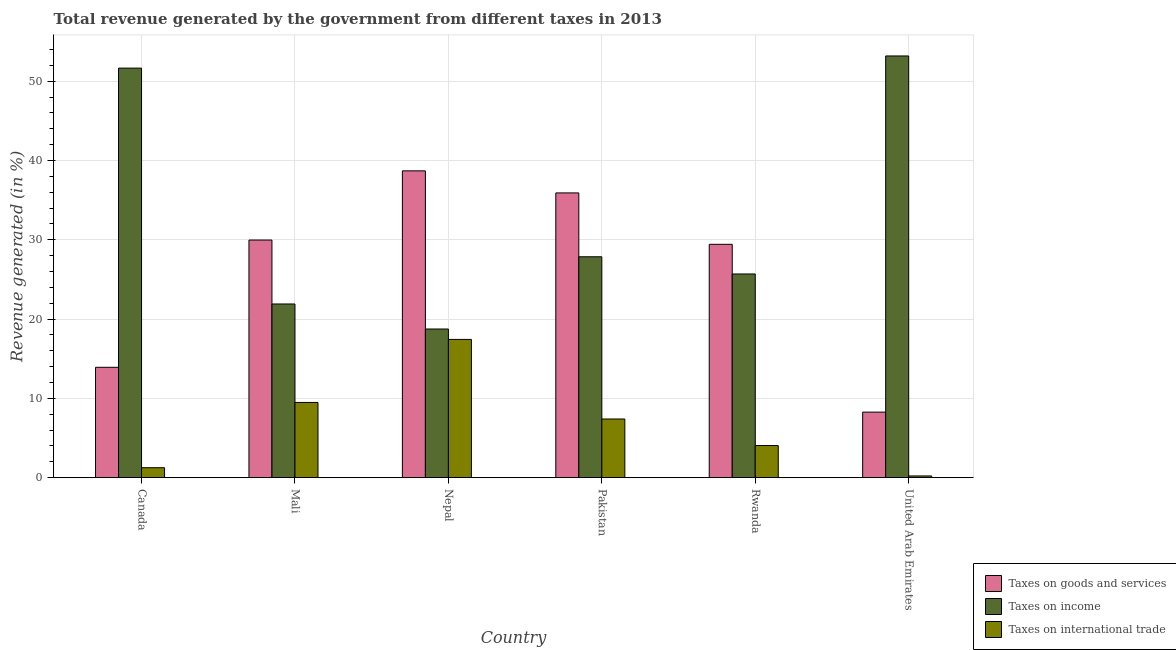How many groups of bars are there?
Offer a terse response. 6. Are the number of bars per tick equal to the number of legend labels?
Offer a terse response. Yes. How many bars are there on the 4th tick from the left?
Provide a short and direct response. 3. How many bars are there on the 2nd tick from the right?
Provide a succinct answer. 3. What is the label of the 2nd group of bars from the left?
Your answer should be very brief. Mali. What is the percentage of revenue generated by taxes on income in Canada?
Your response must be concise. 51.65. Across all countries, what is the maximum percentage of revenue generated by taxes on goods and services?
Your answer should be very brief. 38.69. Across all countries, what is the minimum percentage of revenue generated by taxes on income?
Provide a succinct answer. 18.74. In which country was the percentage of revenue generated by tax on international trade maximum?
Your response must be concise. Nepal. In which country was the percentage of revenue generated by taxes on goods and services minimum?
Keep it short and to the point. United Arab Emirates. What is the total percentage of revenue generated by taxes on income in the graph?
Your response must be concise. 199.02. What is the difference between the percentage of revenue generated by taxes on income in Mali and that in Rwanda?
Ensure brevity in your answer.  -3.78. What is the difference between the percentage of revenue generated by taxes on goods and services in Mali and the percentage of revenue generated by taxes on income in Nepal?
Make the answer very short. 11.22. What is the average percentage of revenue generated by taxes on income per country?
Keep it short and to the point. 33.17. What is the difference between the percentage of revenue generated by taxes on goods and services and percentage of revenue generated by tax on international trade in United Arab Emirates?
Give a very brief answer. 8.05. In how many countries, is the percentage of revenue generated by taxes on goods and services greater than 42 %?
Give a very brief answer. 0. What is the ratio of the percentage of revenue generated by taxes on income in Canada to that in United Arab Emirates?
Give a very brief answer. 0.97. What is the difference between the highest and the second highest percentage of revenue generated by taxes on goods and services?
Your response must be concise. 2.78. What is the difference between the highest and the lowest percentage of revenue generated by taxes on goods and services?
Your answer should be compact. 30.43. Is the sum of the percentage of revenue generated by taxes on income in Mali and United Arab Emirates greater than the maximum percentage of revenue generated by tax on international trade across all countries?
Your answer should be very brief. Yes. What does the 2nd bar from the left in Nepal represents?
Your response must be concise. Taxes on income. What does the 1st bar from the right in Mali represents?
Give a very brief answer. Taxes on international trade. Is it the case that in every country, the sum of the percentage of revenue generated by taxes on goods and services and percentage of revenue generated by taxes on income is greater than the percentage of revenue generated by tax on international trade?
Give a very brief answer. Yes. How many countries are there in the graph?
Make the answer very short. 6. Are the values on the major ticks of Y-axis written in scientific E-notation?
Ensure brevity in your answer.  No. Does the graph contain grids?
Provide a succinct answer. Yes. How many legend labels are there?
Provide a succinct answer. 3. How are the legend labels stacked?
Your response must be concise. Vertical. What is the title of the graph?
Provide a succinct answer. Total revenue generated by the government from different taxes in 2013. What is the label or title of the Y-axis?
Provide a short and direct response. Revenue generated (in %). What is the Revenue generated (in %) of Taxes on goods and services in Canada?
Your response must be concise. 13.91. What is the Revenue generated (in %) in Taxes on income in Canada?
Keep it short and to the point. 51.65. What is the Revenue generated (in %) of Taxes on international trade in Canada?
Your answer should be very brief. 1.25. What is the Revenue generated (in %) of Taxes on goods and services in Mali?
Give a very brief answer. 29.97. What is the Revenue generated (in %) of Taxes on income in Mali?
Keep it short and to the point. 21.9. What is the Revenue generated (in %) of Taxes on international trade in Mali?
Provide a short and direct response. 9.48. What is the Revenue generated (in %) in Taxes on goods and services in Nepal?
Your answer should be compact. 38.69. What is the Revenue generated (in %) in Taxes on income in Nepal?
Give a very brief answer. 18.74. What is the Revenue generated (in %) of Taxes on international trade in Nepal?
Your answer should be compact. 17.43. What is the Revenue generated (in %) in Taxes on goods and services in Pakistan?
Your answer should be compact. 35.91. What is the Revenue generated (in %) in Taxes on income in Pakistan?
Ensure brevity in your answer.  27.85. What is the Revenue generated (in %) of Taxes on international trade in Pakistan?
Give a very brief answer. 7.4. What is the Revenue generated (in %) of Taxes on goods and services in Rwanda?
Offer a terse response. 29.43. What is the Revenue generated (in %) of Taxes on income in Rwanda?
Make the answer very short. 25.69. What is the Revenue generated (in %) of Taxes on international trade in Rwanda?
Provide a short and direct response. 4.05. What is the Revenue generated (in %) of Taxes on goods and services in United Arab Emirates?
Offer a very short reply. 8.26. What is the Revenue generated (in %) of Taxes on income in United Arab Emirates?
Your answer should be very brief. 53.18. What is the Revenue generated (in %) in Taxes on international trade in United Arab Emirates?
Give a very brief answer. 0.21. Across all countries, what is the maximum Revenue generated (in %) in Taxes on goods and services?
Provide a short and direct response. 38.69. Across all countries, what is the maximum Revenue generated (in %) of Taxes on income?
Offer a terse response. 53.18. Across all countries, what is the maximum Revenue generated (in %) in Taxes on international trade?
Ensure brevity in your answer.  17.43. Across all countries, what is the minimum Revenue generated (in %) in Taxes on goods and services?
Ensure brevity in your answer.  8.26. Across all countries, what is the minimum Revenue generated (in %) in Taxes on income?
Keep it short and to the point. 18.74. Across all countries, what is the minimum Revenue generated (in %) of Taxes on international trade?
Provide a short and direct response. 0.21. What is the total Revenue generated (in %) in Taxes on goods and services in the graph?
Provide a short and direct response. 156.17. What is the total Revenue generated (in %) in Taxes on income in the graph?
Offer a terse response. 199.02. What is the total Revenue generated (in %) of Taxes on international trade in the graph?
Ensure brevity in your answer.  39.83. What is the difference between the Revenue generated (in %) in Taxes on goods and services in Canada and that in Mali?
Your answer should be compact. -16.05. What is the difference between the Revenue generated (in %) in Taxes on income in Canada and that in Mali?
Give a very brief answer. 29.75. What is the difference between the Revenue generated (in %) of Taxes on international trade in Canada and that in Mali?
Your answer should be very brief. -8.23. What is the difference between the Revenue generated (in %) in Taxes on goods and services in Canada and that in Nepal?
Your answer should be compact. -24.78. What is the difference between the Revenue generated (in %) in Taxes on income in Canada and that in Nepal?
Make the answer very short. 32.9. What is the difference between the Revenue generated (in %) of Taxes on international trade in Canada and that in Nepal?
Offer a terse response. -16.18. What is the difference between the Revenue generated (in %) in Taxes on goods and services in Canada and that in Pakistan?
Offer a very short reply. -21.99. What is the difference between the Revenue generated (in %) in Taxes on income in Canada and that in Pakistan?
Offer a very short reply. 23.79. What is the difference between the Revenue generated (in %) in Taxes on international trade in Canada and that in Pakistan?
Offer a terse response. -6.14. What is the difference between the Revenue generated (in %) of Taxes on goods and services in Canada and that in Rwanda?
Offer a very short reply. -15.51. What is the difference between the Revenue generated (in %) in Taxes on income in Canada and that in Rwanda?
Give a very brief answer. 25.96. What is the difference between the Revenue generated (in %) of Taxes on international trade in Canada and that in Rwanda?
Provide a succinct answer. -2.8. What is the difference between the Revenue generated (in %) in Taxes on goods and services in Canada and that in United Arab Emirates?
Provide a succinct answer. 5.65. What is the difference between the Revenue generated (in %) of Taxes on income in Canada and that in United Arab Emirates?
Your answer should be very brief. -1.53. What is the difference between the Revenue generated (in %) of Taxes on international trade in Canada and that in United Arab Emirates?
Ensure brevity in your answer.  1.04. What is the difference between the Revenue generated (in %) of Taxes on goods and services in Mali and that in Nepal?
Give a very brief answer. -8.73. What is the difference between the Revenue generated (in %) in Taxes on income in Mali and that in Nepal?
Give a very brief answer. 3.16. What is the difference between the Revenue generated (in %) of Taxes on international trade in Mali and that in Nepal?
Your answer should be very brief. -7.95. What is the difference between the Revenue generated (in %) in Taxes on goods and services in Mali and that in Pakistan?
Give a very brief answer. -5.94. What is the difference between the Revenue generated (in %) in Taxes on income in Mali and that in Pakistan?
Your answer should be compact. -5.95. What is the difference between the Revenue generated (in %) of Taxes on international trade in Mali and that in Pakistan?
Keep it short and to the point. 2.09. What is the difference between the Revenue generated (in %) in Taxes on goods and services in Mali and that in Rwanda?
Offer a terse response. 0.54. What is the difference between the Revenue generated (in %) of Taxes on income in Mali and that in Rwanda?
Your answer should be compact. -3.78. What is the difference between the Revenue generated (in %) of Taxes on international trade in Mali and that in Rwanda?
Offer a terse response. 5.44. What is the difference between the Revenue generated (in %) of Taxes on goods and services in Mali and that in United Arab Emirates?
Make the answer very short. 21.7. What is the difference between the Revenue generated (in %) of Taxes on income in Mali and that in United Arab Emirates?
Your answer should be very brief. -31.28. What is the difference between the Revenue generated (in %) of Taxes on international trade in Mali and that in United Arab Emirates?
Give a very brief answer. 9.27. What is the difference between the Revenue generated (in %) of Taxes on goods and services in Nepal and that in Pakistan?
Your answer should be compact. 2.78. What is the difference between the Revenue generated (in %) of Taxes on income in Nepal and that in Pakistan?
Your answer should be very brief. -9.11. What is the difference between the Revenue generated (in %) in Taxes on international trade in Nepal and that in Pakistan?
Your response must be concise. 10.04. What is the difference between the Revenue generated (in %) in Taxes on goods and services in Nepal and that in Rwanda?
Give a very brief answer. 9.27. What is the difference between the Revenue generated (in %) in Taxes on income in Nepal and that in Rwanda?
Your answer should be very brief. -6.94. What is the difference between the Revenue generated (in %) of Taxes on international trade in Nepal and that in Rwanda?
Make the answer very short. 13.39. What is the difference between the Revenue generated (in %) in Taxes on goods and services in Nepal and that in United Arab Emirates?
Give a very brief answer. 30.43. What is the difference between the Revenue generated (in %) in Taxes on income in Nepal and that in United Arab Emirates?
Ensure brevity in your answer.  -34.44. What is the difference between the Revenue generated (in %) in Taxes on international trade in Nepal and that in United Arab Emirates?
Provide a short and direct response. 17.22. What is the difference between the Revenue generated (in %) of Taxes on goods and services in Pakistan and that in Rwanda?
Provide a short and direct response. 6.48. What is the difference between the Revenue generated (in %) in Taxes on income in Pakistan and that in Rwanda?
Keep it short and to the point. 2.17. What is the difference between the Revenue generated (in %) of Taxes on international trade in Pakistan and that in Rwanda?
Make the answer very short. 3.35. What is the difference between the Revenue generated (in %) of Taxes on goods and services in Pakistan and that in United Arab Emirates?
Your answer should be very brief. 27.65. What is the difference between the Revenue generated (in %) in Taxes on income in Pakistan and that in United Arab Emirates?
Provide a succinct answer. -25.33. What is the difference between the Revenue generated (in %) of Taxes on international trade in Pakistan and that in United Arab Emirates?
Ensure brevity in your answer.  7.18. What is the difference between the Revenue generated (in %) in Taxes on goods and services in Rwanda and that in United Arab Emirates?
Make the answer very short. 21.16. What is the difference between the Revenue generated (in %) of Taxes on income in Rwanda and that in United Arab Emirates?
Offer a terse response. -27.5. What is the difference between the Revenue generated (in %) of Taxes on international trade in Rwanda and that in United Arab Emirates?
Your answer should be very brief. 3.83. What is the difference between the Revenue generated (in %) in Taxes on goods and services in Canada and the Revenue generated (in %) in Taxes on income in Mali?
Provide a succinct answer. -7.99. What is the difference between the Revenue generated (in %) in Taxes on goods and services in Canada and the Revenue generated (in %) in Taxes on international trade in Mali?
Keep it short and to the point. 4.43. What is the difference between the Revenue generated (in %) in Taxes on income in Canada and the Revenue generated (in %) in Taxes on international trade in Mali?
Your answer should be compact. 42.17. What is the difference between the Revenue generated (in %) of Taxes on goods and services in Canada and the Revenue generated (in %) of Taxes on income in Nepal?
Keep it short and to the point. -4.83. What is the difference between the Revenue generated (in %) in Taxes on goods and services in Canada and the Revenue generated (in %) in Taxes on international trade in Nepal?
Offer a terse response. -3.52. What is the difference between the Revenue generated (in %) in Taxes on income in Canada and the Revenue generated (in %) in Taxes on international trade in Nepal?
Your response must be concise. 34.22. What is the difference between the Revenue generated (in %) of Taxes on goods and services in Canada and the Revenue generated (in %) of Taxes on income in Pakistan?
Offer a very short reply. -13.94. What is the difference between the Revenue generated (in %) of Taxes on goods and services in Canada and the Revenue generated (in %) of Taxes on international trade in Pakistan?
Make the answer very short. 6.52. What is the difference between the Revenue generated (in %) in Taxes on income in Canada and the Revenue generated (in %) in Taxes on international trade in Pakistan?
Give a very brief answer. 44.25. What is the difference between the Revenue generated (in %) of Taxes on goods and services in Canada and the Revenue generated (in %) of Taxes on income in Rwanda?
Your response must be concise. -11.77. What is the difference between the Revenue generated (in %) in Taxes on goods and services in Canada and the Revenue generated (in %) in Taxes on international trade in Rwanda?
Your answer should be compact. 9.87. What is the difference between the Revenue generated (in %) of Taxes on income in Canada and the Revenue generated (in %) of Taxes on international trade in Rwanda?
Your answer should be very brief. 47.6. What is the difference between the Revenue generated (in %) of Taxes on goods and services in Canada and the Revenue generated (in %) of Taxes on income in United Arab Emirates?
Make the answer very short. -39.27. What is the difference between the Revenue generated (in %) of Taxes on goods and services in Canada and the Revenue generated (in %) of Taxes on international trade in United Arab Emirates?
Give a very brief answer. 13.7. What is the difference between the Revenue generated (in %) of Taxes on income in Canada and the Revenue generated (in %) of Taxes on international trade in United Arab Emirates?
Your response must be concise. 51.44. What is the difference between the Revenue generated (in %) in Taxes on goods and services in Mali and the Revenue generated (in %) in Taxes on income in Nepal?
Give a very brief answer. 11.22. What is the difference between the Revenue generated (in %) in Taxes on goods and services in Mali and the Revenue generated (in %) in Taxes on international trade in Nepal?
Offer a very short reply. 12.53. What is the difference between the Revenue generated (in %) in Taxes on income in Mali and the Revenue generated (in %) in Taxes on international trade in Nepal?
Make the answer very short. 4.47. What is the difference between the Revenue generated (in %) in Taxes on goods and services in Mali and the Revenue generated (in %) in Taxes on income in Pakistan?
Give a very brief answer. 2.11. What is the difference between the Revenue generated (in %) of Taxes on goods and services in Mali and the Revenue generated (in %) of Taxes on international trade in Pakistan?
Ensure brevity in your answer.  22.57. What is the difference between the Revenue generated (in %) in Taxes on income in Mali and the Revenue generated (in %) in Taxes on international trade in Pakistan?
Provide a succinct answer. 14.51. What is the difference between the Revenue generated (in %) in Taxes on goods and services in Mali and the Revenue generated (in %) in Taxes on income in Rwanda?
Give a very brief answer. 4.28. What is the difference between the Revenue generated (in %) of Taxes on goods and services in Mali and the Revenue generated (in %) of Taxes on international trade in Rwanda?
Offer a very short reply. 25.92. What is the difference between the Revenue generated (in %) of Taxes on income in Mali and the Revenue generated (in %) of Taxes on international trade in Rwanda?
Give a very brief answer. 17.86. What is the difference between the Revenue generated (in %) of Taxes on goods and services in Mali and the Revenue generated (in %) of Taxes on income in United Arab Emirates?
Your answer should be compact. -23.22. What is the difference between the Revenue generated (in %) of Taxes on goods and services in Mali and the Revenue generated (in %) of Taxes on international trade in United Arab Emirates?
Give a very brief answer. 29.75. What is the difference between the Revenue generated (in %) in Taxes on income in Mali and the Revenue generated (in %) in Taxes on international trade in United Arab Emirates?
Your answer should be compact. 21.69. What is the difference between the Revenue generated (in %) of Taxes on goods and services in Nepal and the Revenue generated (in %) of Taxes on income in Pakistan?
Give a very brief answer. 10.84. What is the difference between the Revenue generated (in %) in Taxes on goods and services in Nepal and the Revenue generated (in %) in Taxes on international trade in Pakistan?
Ensure brevity in your answer.  31.3. What is the difference between the Revenue generated (in %) in Taxes on income in Nepal and the Revenue generated (in %) in Taxes on international trade in Pakistan?
Offer a very short reply. 11.35. What is the difference between the Revenue generated (in %) of Taxes on goods and services in Nepal and the Revenue generated (in %) of Taxes on income in Rwanda?
Provide a succinct answer. 13.01. What is the difference between the Revenue generated (in %) of Taxes on goods and services in Nepal and the Revenue generated (in %) of Taxes on international trade in Rwanda?
Provide a short and direct response. 34.64. What is the difference between the Revenue generated (in %) of Taxes on income in Nepal and the Revenue generated (in %) of Taxes on international trade in Rwanda?
Provide a short and direct response. 14.7. What is the difference between the Revenue generated (in %) in Taxes on goods and services in Nepal and the Revenue generated (in %) in Taxes on income in United Arab Emirates?
Ensure brevity in your answer.  -14.49. What is the difference between the Revenue generated (in %) of Taxes on goods and services in Nepal and the Revenue generated (in %) of Taxes on international trade in United Arab Emirates?
Keep it short and to the point. 38.48. What is the difference between the Revenue generated (in %) in Taxes on income in Nepal and the Revenue generated (in %) in Taxes on international trade in United Arab Emirates?
Make the answer very short. 18.53. What is the difference between the Revenue generated (in %) in Taxes on goods and services in Pakistan and the Revenue generated (in %) in Taxes on income in Rwanda?
Keep it short and to the point. 10.22. What is the difference between the Revenue generated (in %) of Taxes on goods and services in Pakistan and the Revenue generated (in %) of Taxes on international trade in Rwanda?
Your response must be concise. 31.86. What is the difference between the Revenue generated (in %) in Taxes on income in Pakistan and the Revenue generated (in %) in Taxes on international trade in Rwanda?
Give a very brief answer. 23.81. What is the difference between the Revenue generated (in %) of Taxes on goods and services in Pakistan and the Revenue generated (in %) of Taxes on income in United Arab Emirates?
Provide a short and direct response. -17.27. What is the difference between the Revenue generated (in %) in Taxes on goods and services in Pakistan and the Revenue generated (in %) in Taxes on international trade in United Arab Emirates?
Your answer should be compact. 35.7. What is the difference between the Revenue generated (in %) in Taxes on income in Pakistan and the Revenue generated (in %) in Taxes on international trade in United Arab Emirates?
Give a very brief answer. 27.64. What is the difference between the Revenue generated (in %) of Taxes on goods and services in Rwanda and the Revenue generated (in %) of Taxes on income in United Arab Emirates?
Offer a terse response. -23.76. What is the difference between the Revenue generated (in %) in Taxes on goods and services in Rwanda and the Revenue generated (in %) in Taxes on international trade in United Arab Emirates?
Provide a succinct answer. 29.21. What is the difference between the Revenue generated (in %) in Taxes on income in Rwanda and the Revenue generated (in %) in Taxes on international trade in United Arab Emirates?
Ensure brevity in your answer.  25.47. What is the average Revenue generated (in %) of Taxes on goods and services per country?
Ensure brevity in your answer.  26.03. What is the average Revenue generated (in %) of Taxes on income per country?
Your response must be concise. 33.17. What is the average Revenue generated (in %) of Taxes on international trade per country?
Ensure brevity in your answer.  6.64. What is the difference between the Revenue generated (in %) in Taxes on goods and services and Revenue generated (in %) in Taxes on income in Canada?
Provide a short and direct response. -37.73. What is the difference between the Revenue generated (in %) in Taxes on goods and services and Revenue generated (in %) in Taxes on international trade in Canada?
Your answer should be compact. 12.66. What is the difference between the Revenue generated (in %) of Taxes on income and Revenue generated (in %) of Taxes on international trade in Canada?
Give a very brief answer. 50.4. What is the difference between the Revenue generated (in %) of Taxes on goods and services and Revenue generated (in %) of Taxes on income in Mali?
Your answer should be compact. 8.06. What is the difference between the Revenue generated (in %) of Taxes on goods and services and Revenue generated (in %) of Taxes on international trade in Mali?
Ensure brevity in your answer.  20.48. What is the difference between the Revenue generated (in %) in Taxes on income and Revenue generated (in %) in Taxes on international trade in Mali?
Provide a short and direct response. 12.42. What is the difference between the Revenue generated (in %) in Taxes on goods and services and Revenue generated (in %) in Taxes on income in Nepal?
Keep it short and to the point. 19.95. What is the difference between the Revenue generated (in %) in Taxes on goods and services and Revenue generated (in %) in Taxes on international trade in Nepal?
Offer a terse response. 21.26. What is the difference between the Revenue generated (in %) in Taxes on income and Revenue generated (in %) in Taxes on international trade in Nepal?
Your response must be concise. 1.31. What is the difference between the Revenue generated (in %) of Taxes on goods and services and Revenue generated (in %) of Taxes on income in Pakistan?
Keep it short and to the point. 8.05. What is the difference between the Revenue generated (in %) of Taxes on goods and services and Revenue generated (in %) of Taxes on international trade in Pakistan?
Offer a very short reply. 28.51. What is the difference between the Revenue generated (in %) of Taxes on income and Revenue generated (in %) of Taxes on international trade in Pakistan?
Offer a terse response. 20.46. What is the difference between the Revenue generated (in %) of Taxes on goods and services and Revenue generated (in %) of Taxes on income in Rwanda?
Keep it short and to the point. 3.74. What is the difference between the Revenue generated (in %) in Taxes on goods and services and Revenue generated (in %) in Taxes on international trade in Rwanda?
Keep it short and to the point. 25.38. What is the difference between the Revenue generated (in %) of Taxes on income and Revenue generated (in %) of Taxes on international trade in Rwanda?
Ensure brevity in your answer.  21.64. What is the difference between the Revenue generated (in %) in Taxes on goods and services and Revenue generated (in %) in Taxes on income in United Arab Emirates?
Offer a very short reply. -44.92. What is the difference between the Revenue generated (in %) in Taxes on goods and services and Revenue generated (in %) in Taxes on international trade in United Arab Emirates?
Keep it short and to the point. 8.05. What is the difference between the Revenue generated (in %) of Taxes on income and Revenue generated (in %) of Taxes on international trade in United Arab Emirates?
Give a very brief answer. 52.97. What is the ratio of the Revenue generated (in %) of Taxes on goods and services in Canada to that in Mali?
Your answer should be very brief. 0.46. What is the ratio of the Revenue generated (in %) of Taxes on income in Canada to that in Mali?
Ensure brevity in your answer.  2.36. What is the ratio of the Revenue generated (in %) in Taxes on international trade in Canada to that in Mali?
Offer a very short reply. 0.13. What is the ratio of the Revenue generated (in %) in Taxes on goods and services in Canada to that in Nepal?
Give a very brief answer. 0.36. What is the ratio of the Revenue generated (in %) in Taxes on income in Canada to that in Nepal?
Ensure brevity in your answer.  2.76. What is the ratio of the Revenue generated (in %) of Taxes on international trade in Canada to that in Nepal?
Make the answer very short. 0.07. What is the ratio of the Revenue generated (in %) of Taxes on goods and services in Canada to that in Pakistan?
Offer a terse response. 0.39. What is the ratio of the Revenue generated (in %) in Taxes on income in Canada to that in Pakistan?
Make the answer very short. 1.85. What is the ratio of the Revenue generated (in %) of Taxes on international trade in Canada to that in Pakistan?
Ensure brevity in your answer.  0.17. What is the ratio of the Revenue generated (in %) of Taxes on goods and services in Canada to that in Rwanda?
Your response must be concise. 0.47. What is the ratio of the Revenue generated (in %) of Taxes on income in Canada to that in Rwanda?
Ensure brevity in your answer.  2.01. What is the ratio of the Revenue generated (in %) of Taxes on international trade in Canada to that in Rwanda?
Keep it short and to the point. 0.31. What is the ratio of the Revenue generated (in %) of Taxes on goods and services in Canada to that in United Arab Emirates?
Keep it short and to the point. 1.68. What is the ratio of the Revenue generated (in %) in Taxes on income in Canada to that in United Arab Emirates?
Provide a succinct answer. 0.97. What is the ratio of the Revenue generated (in %) of Taxes on international trade in Canada to that in United Arab Emirates?
Provide a succinct answer. 5.84. What is the ratio of the Revenue generated (in %) in Taxes on goods and services in Mali to that in Nepal?
Provide a short and direct response. 0.77. What is the ratio of the Revenue generated (in %) in Taxes on income in Mali to that in Nepal?
Provide a succinct answer. 1.17. What is the ratio of the Revenue generated (in %) in Taxes on international trade in Mali to that in Nepal?
Offer a terse response. 0.54. What is the ratio of the Revenue generated (in %) in Taxes on goods and services in Mali to that in Pakistan?
Give a very brief answer. 0.83. What is the ratio of the Revenue generated (in %) in Taxes on income in Mali to that in Pakistan?
Provide a succinct answer. 0.79. What is the ratio of the Revenue generated (in %) in Taxes on international trade in Mali to that in Pakistan?
Provide a succinct answer. 1.28. What is the ratio of the Revenue generated (in %) of Taxes on goods and services in Mali to that in Rwanda?
Provide a succinct answer. 1.02. What is the ratio of the Revenue generated (in %) of Taxes on income in Mali to that in Rwanda?
Provide a short and direct response. 0.85. What is the ratio of the Revenue generated (in %) in Taxes on international trade in Mali to that in Rwanda?
Make the answer very short. 2.34. What is the ratio of the Revenue generated (in %) in Taxes on goods and services in Mali to that in United Arab Emirates?
Provide a short and direct response. 3.63. What is the ratio of the Revenue generated (in %) of Taxes on income in Mali to that in United Arab Emirates?
Provide a short and direct response. 0.41. What is the ratio of the Revenue generated (in %) in Taxes on international trade in Mali to that in United Arab Emirates?
Your answer should be compact. 44.25. What is the ratio of the Revenue generated (in %) in Taxes on goods and services in Nepal to that in Pakistan?
Provide a succinct answer. 1.08. What is the ratio of the Revenue generated (in %) in Taxes on income in Nepal to that in Pakistan?
Give a very brief answer. 0.67. What is the ratio of the Revenue generated (in %) in Taxes on international trade in Nepal to that in Pakistan?
Provide a short and direct response. 2.36. What is the ratio of the Revenue generated (in %) of Taxes on goods and services in Nepal to that in Rwanda?
Offer a terse response. 1.31. What is the ratio of the Revenue generated (in %) in Taxes on income in Nepal to that in Rwanda?
Give a very brief answer. 0.73. What is the ratio of the Revenue generated (in %) of Taxes on international trade in Nepal to that in Rwanda?
Keep it short and to the point. 4.31. What is the ratio of the Revenue generated (in %) of Taxes on goods and services in Nepal to that in United Arab Emirates?
Provide a succinct answer. 4.68. What is the ratio of the Revenue generated (in %) in Taxes on income in Nepal to that in United Arab Emirates?
Offer a terse response. 0.35. What is the ratio of the Revenue generated (in %) of Taxes on international trade in Nepal to that in United Arab Emirates?
Offer a terse response. 81.35. What is the ratio of the Revenue generated (in %) in Taxes on goods and services in Pakistan to that in Rwanda?
Offer a terse response. 1.22. What is the ratio of the Revenue generated (in %) in Taxes on income in Pakistan to that in Rwanda?
Make the answer very short. 1.08. What is the ratio of the Revenue generated (in %) of Taxes on international trade in Pakistan to that in Rwanda?
Offer a very short reply. 1.83. What is the ratio of the Revenue generated (in %) of Taxes on goods and services in Pakistan to that in United Arab Emirates?
Keep it short and to the point. 4.35. What is the ratio of the Revenue generated (in %) in Taxes on income in Pakistan to that in United Arab Emirates?
Your answer should be very brief. 0.52. What is the ratio of the Revenue generated (in %) of Taxes on international trade in Pakistan to that in United Arab Emirates?
Your answer should be compact. 34.52. What is the ratio of the Revenue generated (in %) of Taxes on goods and services in Rwanda to that in United Arab Emirates?
Offer a terse response. 3.56. What is the ratio of the Revenue generated (in %) in Taxes on income in Rwanda to that in United Arab Emirates?
Make the answer very short. 0.48. What is the ratio of the Revenue generated (in %) in Taxes on international trade in Rwanda to that in United Arab Emirates?
Provide a short and direct response. 18.89. What is the difference between the highest and the second highest Revenue generated (in %) of Taxes on goods and services?
Your answer should be compact. 2.78. What is the difference between the highest and the second highest Revenue generated (in %) in Taxes on income?
Make the answer very short. 1.53. What is the difference between the highest and the second highest Revenue generated (in %) of Taxes on international trade?
Give a very brief answer. 7.95. What is the difference between the highest and the lowest Revenue generated (in %) in Taxes on goods and services?
Offer a terse response. 30.43. What is the difference between the highest and the lowest Revenue generated (in %) in Taxes on income?
Make the answer very short. 34.44. What is the difference between the highest and the lowest Revenue generated (in %) in Taxes on international trade?
Your answer should be compact. 17.22. 